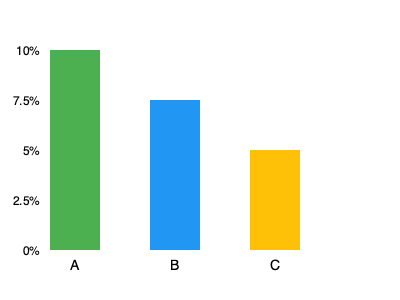Based on the bar graph showing interest rates for different loan options, which option has the lowest interest rate and by how much compared to the highest rate? To answer this question, we need to follow these steps:

1. Identify the interest rates for each option:
   Option A: 10%
   Option B: 7.5%
   Option C: 5%

2. Determine the lowest interest rate:
   The lowest rate is Option C at 5%

3. Determine the highest interest rate:
   The highest rate is Option A at 10%

4. Calculate the difference between the highest and lowest rates:
   $10\% - 5\% = 5\%$

Therefore, Option C has the lowest interest rate, which is 5% lower than the highest rate (Option A).
Answer: Option C; 5% lower 